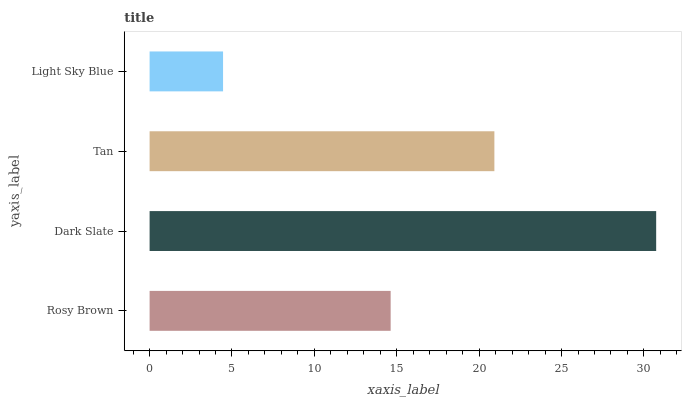Is Light Sky Blue the minimum?
Answer yes or no. Yes. Is Dark Slate the maximum?
Answer yes or no. Yes. Is Tan the minimum?
Answer yes or no. No. Is Tan the maximum?
Answer yes or no. No. Is Dark Slate greater than Tan?
Answer yes or no. Yes. Is Tan less than Dark Slate?
Answer yes or no. Yes. Is Tan greater than Dark Slate?
Answer yes or no. No. Is Dark Slate less than Tan?
Answer yes or no. No. Is Tan the high median?
Answer yes or no. Yes. Is Rosy Brown the low median?
Answer yes or no. Yes. Is Dark Slate the high median?
Answer yes or no. No. Is Tan the low median?
Answer yes or no. No. 